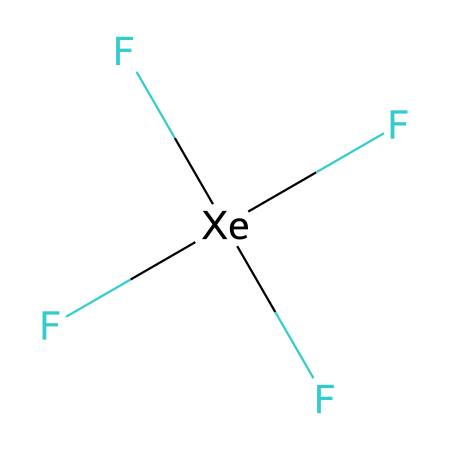What is the central atom in xenon tetrafluoride? The central atom in this compound is indicated by the element symbol Xe, which is at the center of the structure surrounded by four fluorine atoms.
Answer: xenon How many fluorine atoms are bonded to the central xenon atom? The SMILES representation shows four instances of F directly connected to the xenon atom, indicating that there are four fluorine atoms bonded to it.
Answer: four What type of hybridization does the xenon atom exhibit in xenon tetrafluoride? In xenon tetrafluoride, the central xenon atom is bonded to four fluorine atoms, indicating sp³d hybridization is present due to its ability to accommodate five pairs of electrons, which includes one lone pair.
Answer: sp³d Is xenon tetrafluoride a polar or nonpolar molecule? The symmetrical tetrahedral structure resulting from the equivalent fluorine atoms surrounding the central atom leads to a net dipole moment of zero, indicating that it is a nonpolar molecule.
Answer: nonpolar What is the total number of bonds in the xenon tetrafluoride molecule? Each fluorine atom forms one single bond with the central xenon atom, totaling four bonds in the molecule.
Answer: four What distinguishes xenon tetrafluoride as a hypervalent compound? The term hypervalent refers to xenon's ability to have more than eight valence electrons around it; in this case, xenon has a total of twelve electrons considering its bonding with the four fluorine atoms.
Answer: more than eight What is the molecular geometry of xenon tetrafluoride? The arrangement of four fluorine atoms around the xenon atom creates a tetrahedral geometry, which is characteristic of this type of molecular structure.
Answer: tetrahedral 